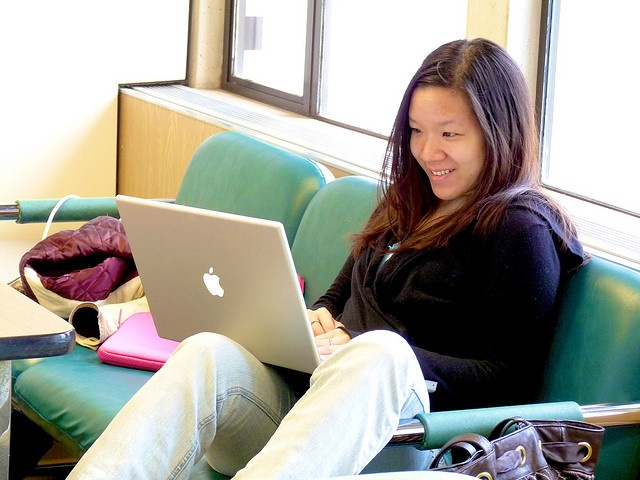Describe the objects in this image and their specific colors. I can see people in white, black, ivory, gray, and maroon tones, couch in white, teal, and turquoise tones, laptop in white, tan, and ivory tones, handbag in white, black, gray, and darkgray tones, and apple in white, darkgray, tan, and lightgray tones in this image. 